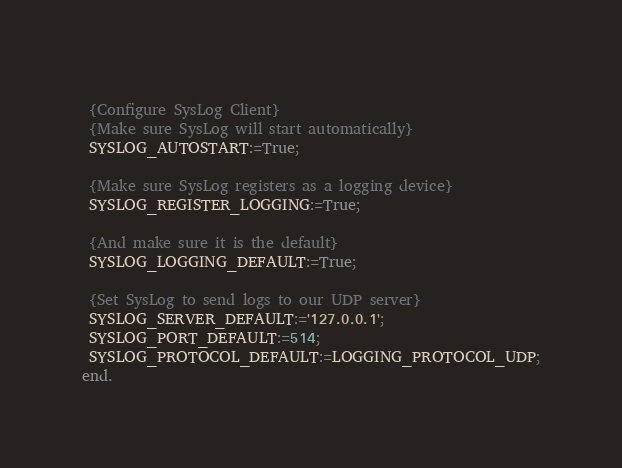Convert code to text. <code><loc_0><loc_0><loc_500><loc_500><_Pascal_> 
 {Configure SysLog Client}
 {Make sure SysLog will start automatically}
 SYSLOG_AUTOSTART:=True; 
 
 {Make sure SysLog registers as a logging device}
 SYSLOG_REGISTER_LOGGING:=True; 
 
 {And make sure it is the default}
 SYSLOG_LOGGING_DEFAULT:=True; 
 
 {Set SysLog to send logs to our UDP server}
 SYSLOG_SERVER_DEFAULT:='127.0.0.1';
 SYSLOG_PORT_DEFAULT:=514;
 SYSLOG_PROTOCOL_DEFAULT:=LOGGING_PROTOCOL_UDP;
end.

</code> 